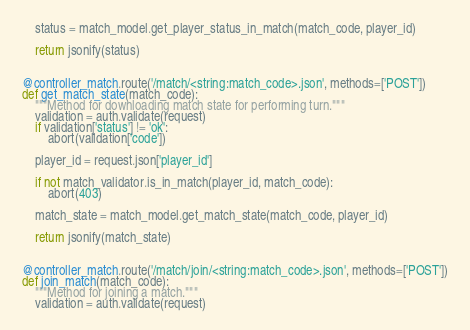<code> <loc_0><loc_0><loc_500><loc_500><_Python_>    status = match_model.get_player_status_in_match(match_code, player_id)

    return jsonify(status)


@controller_match.route('/match/<string:match_code>.json', methods=['POST'])
def get_match_state(match_code):
    """Method for downloading match state for performing turn."""
    validation = auth.validate(request)
    if validation['status'] != 'ok':
        abort(validation['code'])

    player_id = request.json['player_id']

    if not match_validator.is_in_match(player_id, match_code):
        abort(403)

    match_state = match_model.get_match_state(match_code, player_id)

    return jsonify(match_state)


@controller_match.route('/match/join/<string:match_code>.json', methods=['POST'])
def join_match(match_code):
    """Method for joining a match."""
    validation = auth.validate(request)</code> 